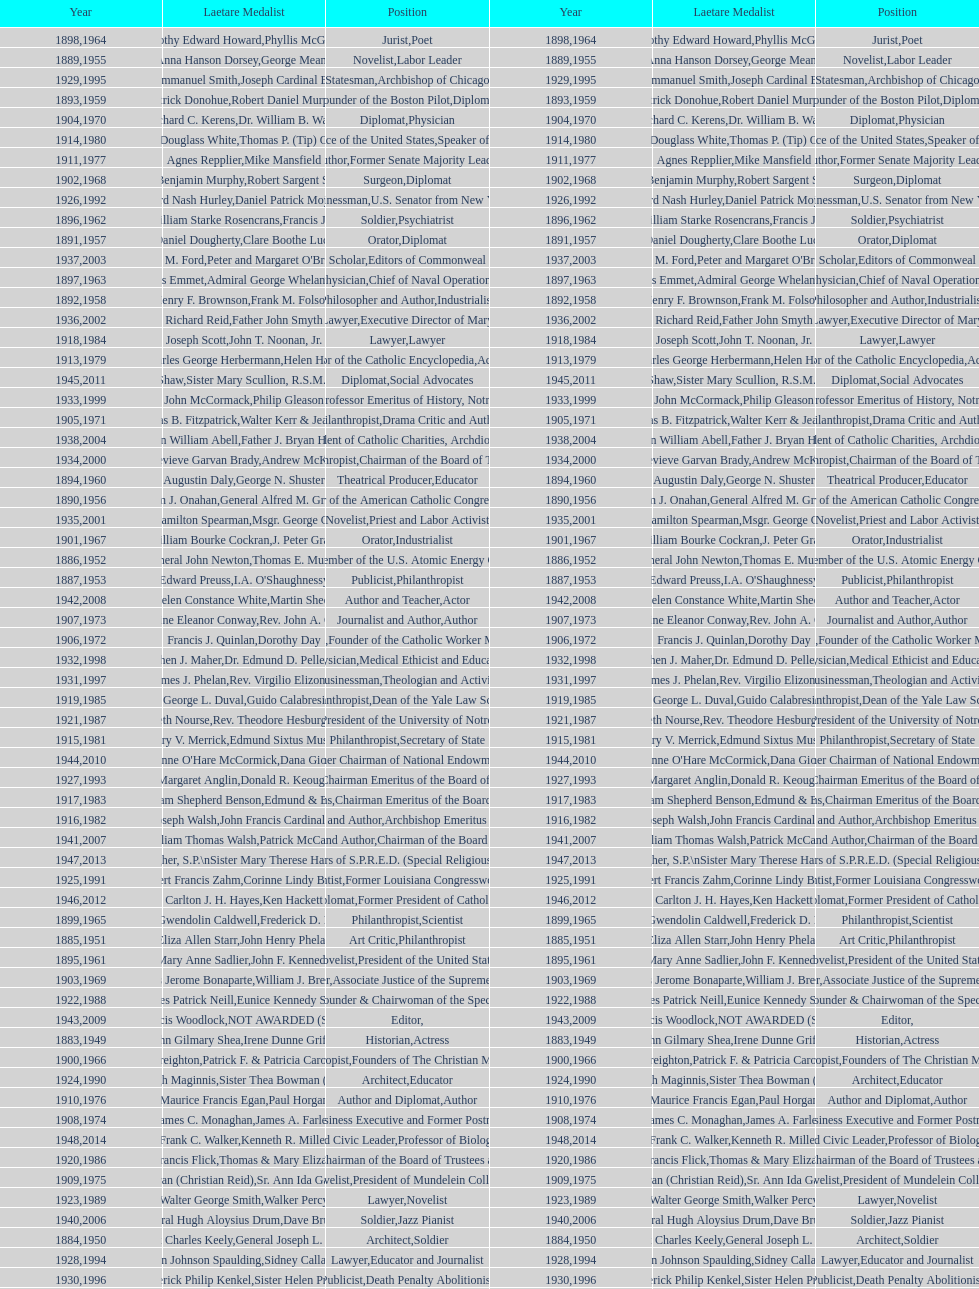How many laetare medalists were philantrohpists? 2. 